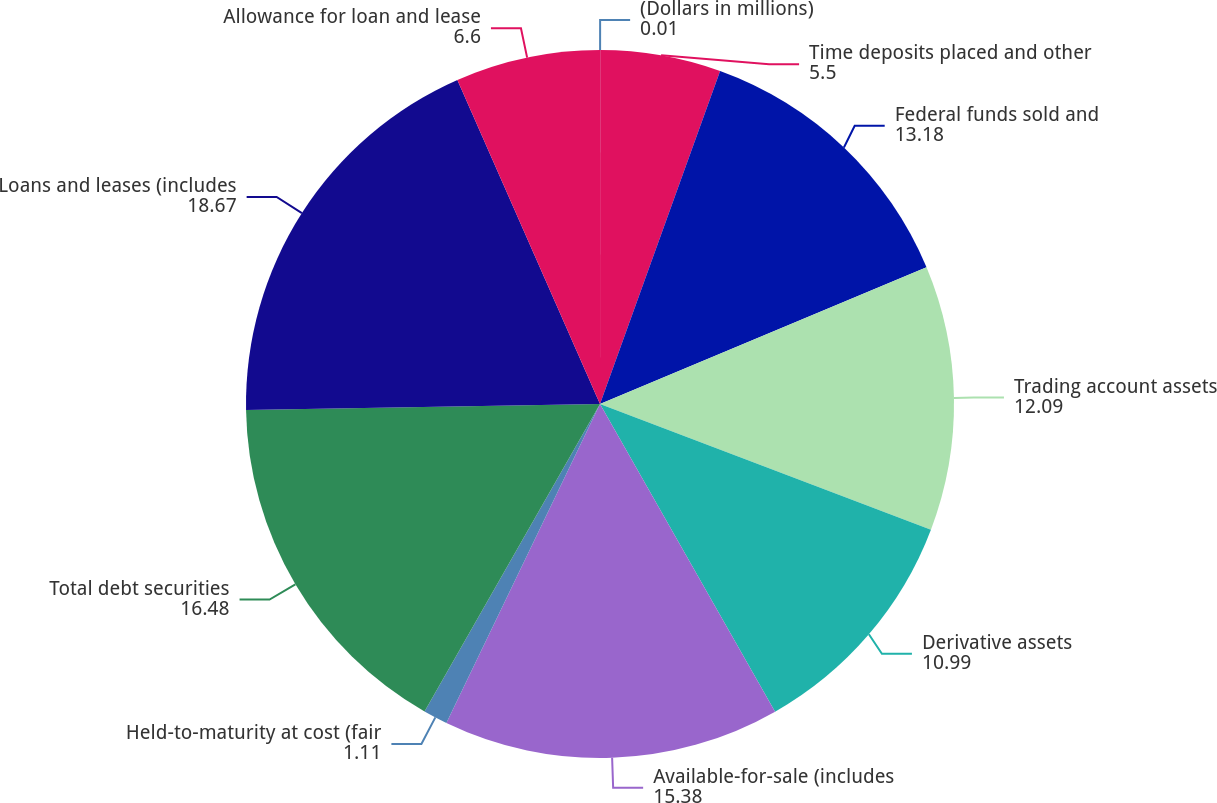<chart> <loc_0><loc_0><loc_500><loc_500><pie_chart><fcel>(Dollars in millions)<fcel>Time deposits placed and other<fcel>Federal funds sold and<fcel>Trading account assets<fcel>Derivative assets<fcel>Available-for-sale (includes<fcel>Held-to-maturity at cost (fair<fcel>Total debt securities<fcel>Loans and leases (includes<fcel>Allowance for loan and lease<nl><fcel>0.01%<fcel>5.5%<fcel>13.18%<fcel>12.09%<fcel>10.99%<fcel>15.38%<fcel>1.11%<fcel>16.48%<fcel>18.67%<fcel>6.6%<nl></chart> 